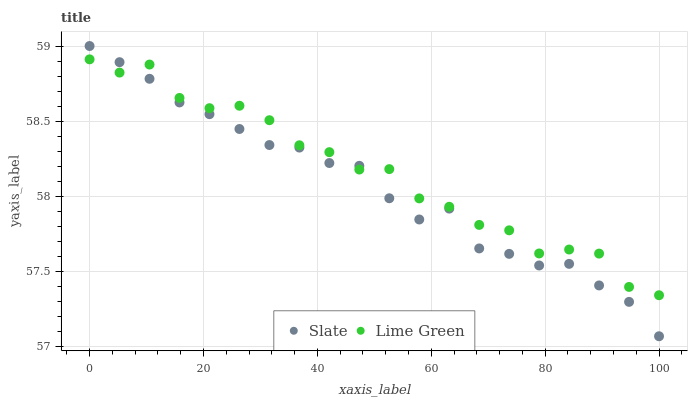Does Slate have the minimum area under the curve?
Answer yes or no. Yes. Does Lime Green have the maximum area under the curve?
Answer yes or no. Yes. Does Lime Green have the minimum area under the curve?
Answer yes or no. No. Is Slate the smoothest?
Answer yes or no. Yes. Is Lime Green the roughest?
Answer yes or no. Yes. Is Lime Green the smoothest?
Answer yes or no. No. Does Slate have the lowest value?
Answer yes or no. Yes. Does Lime Green have the lowest value?
Answer yes or no. No. Does Slate have the highest value?
Answer yes or no. Yes. Does Lime Green have the highest value?
Answer yes or no. No. Does Lime Green intersect Slate?
Answer yes or no. Yes. Is Lime Green less than Slate?
Answer yes or no. No. Is Lime Green greater than Slate?
Answer yes or no. No. 